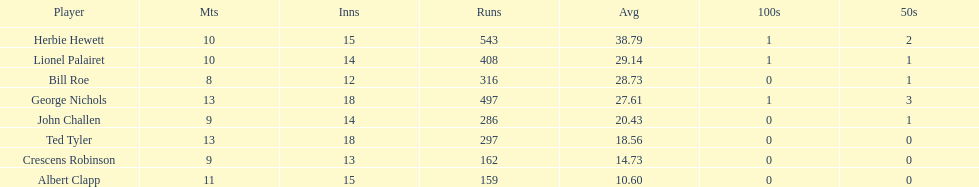By how many runs does john exceed albert? 127. 